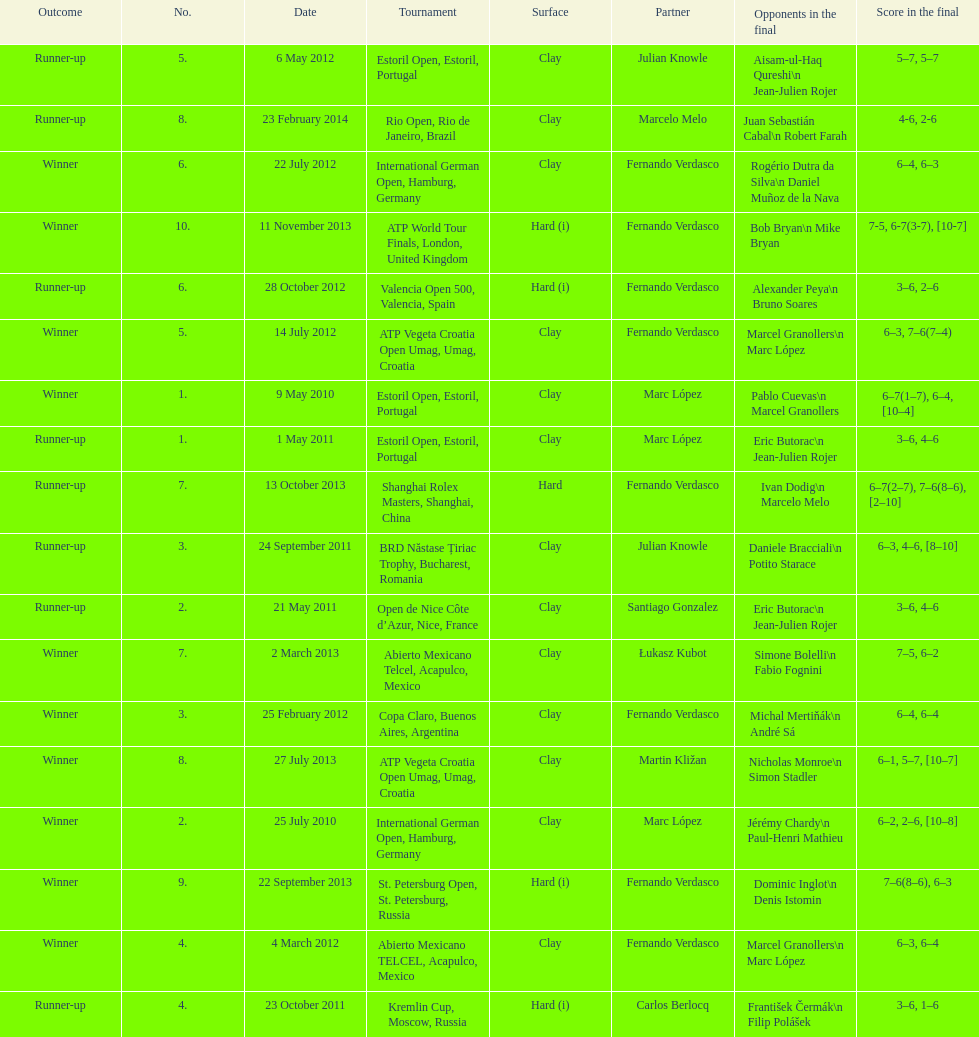What is the number of winning outcomes? 10. Parse the table in full. {'header': ['Outcome', 'No.', 'Date', 'Tournament', 'Surface', 'Partner', 'Opponents in the final', 'Score in the final'], 'rows': [['Runner-up', '5.', '6 May 2012', 'Estoril Open, Estoril, Portugal', 'Clay', 'Julian Knowle', 'Aisam-ul-Haq Qureshi\\n Jean-Julien Rojer', '5–7, 5–7'], ['Runner-up', '8.', '23 February 2014', 'Rio Open, Rio de Janeiro, Brazil', 'Clay', 'Marcelo Melo', 'Juan Sebastián Cabal\\n Robert Farah', '4-6, 2-6'], ['Winner', '6.', '22 July 2012', 'International German Open, Hamburg, Germany', 'Clay', 'Fernando Verdasco', 'Rogério Dutra da Silva\\n Daniel Muñoz de la Nava', '6–4, 6–3'], ['Winner', '10.', '11 November 2013', 'ATP World Tour Finals, London, United Kingdom', 'Hard (i)', 'Fernando Verdasco', 'Bob Bryan\\n Mike Bryan', '7-5, 6-7(3-7), [10-7]'], ['Runner-up', '6.', '28 October 2012', 'Valencia Open 500, Valencia, Spain', 'Hard (i)', 'Fernando Verdasco', 'Alexander Peya\\n Bruno Soares', '3–6, 2–6'], ['Winner', '5.', '14 July 2012', 'ATP Vegeta Croatia Open Umag, Umag, Croatia', 'Clay', 'Fernando Verdasco', 'Marcel Granollers\\n Marc López', '6–3, 7–6(7–4)'], ['Winner', '1.', '9 May 2010', 'Estoril Open, Estoril, Portugal', 'Clay', 'Marc López', 'Pablo Cuevas\\n Marcel Granollers', '6–7(1–7), 6–4, [10–4]'], ['Runner-up', '1.', '1 May 2011', 'Estoril Open, Estoril, Portugal', 'Clay', 'Marc López', 'Eric Butorac\\n Jean-Julien Rojer', '3–6, 4–6'], ['Runner-up', '7.', '13 October 2013', 'Shanghai Rolex Masters, Shanghai, China', 'Hard', 'Fernando Verdasco', 'Ivan Dodig\\n Marcelo Melo', '6–7(2–7), 7–6(8–6), [2–10]'], ['Runner-up', '3.', '24 September 2011', 'BRD Năstase Țiriac Trophy, Bucharest, Romania', 'Clay', 'Julian Knowle', 'Daniele Bracciali\\n Potito Starace', '6–3, 4–6, [8–10]'], ['Runner-up', '2.', '21 May 2011', 'Open de Nice Côte d’Azur, Nice, France', 'Clay', 'Santiago Gonzalez', 'Eric Butorac\\n Jean-Julien Rojer', '3–6, 4–6'], ['Winner', '7.', '2 March 2013', 'Abierto Mexicano Telcel, Acapulco, Mexico', 'Clay', 'Łukasz Kubot', 'Simone Bolelli\\n Fabio Fognini', '7–5, 6–2'], ['Winner', '3.', '25 February 2012', 'Copa Claro, Buenos Aires, Argentina', 'Clay', 'Fernando Verdasco', 'Michal Mertiňák\\n André Sá', '6–4, 6–4'], ['Winner', '8.', '27 July 2013', 'ATP Vegeta Croatia Open Umag, Umag, Croatia', 'Clay', 'Martin Kližan', 'Nicholas Monroe\\n Simon Stadler', '6–1, 5–7, [10–7]'], ['Winner', '2.', '25 July 2010', 'International German Open, Hamburg, Germany', 'Clay', 'Marc López', 'Jérémy Chardy\\n Paul-Henri Mathieu', '6–2, 2–6, [10–8]'], ['Winner', '9.', '22 September 2013', 'St. Petersburg Open, St. Petersburg, Russia', 'Hard (i)', 'Fernando Verdasco', 'Dominic Inglot\\n Denis Istomin', '7–6(8–6), 6–3'], ['Winner', '4.', '4 March 2012', 'Abierto Mexicano TELCEL, Acapulco, Mexico', 'Clay', 'Fernando Verdasco', 'Marcel Granollers\\n Marc López', '6–3, 6–4'], ['Runner-up', '4.', '23 October 2011', 'Kremlin Cup, Moscow, Russia', 'Hard (i)', 'Carlos Berlocq', 'František Čermák\\n Filip Polášek', '3–6, 1–6']]} 